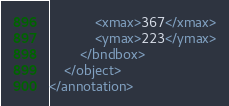<code> <loc_0><loc_0><loc_500><loc_500><_XML_>			<xmax>367</xmax>
			<ymax>223</ymax>
		</bndbox>
	</object>
</annotation>
</code> 